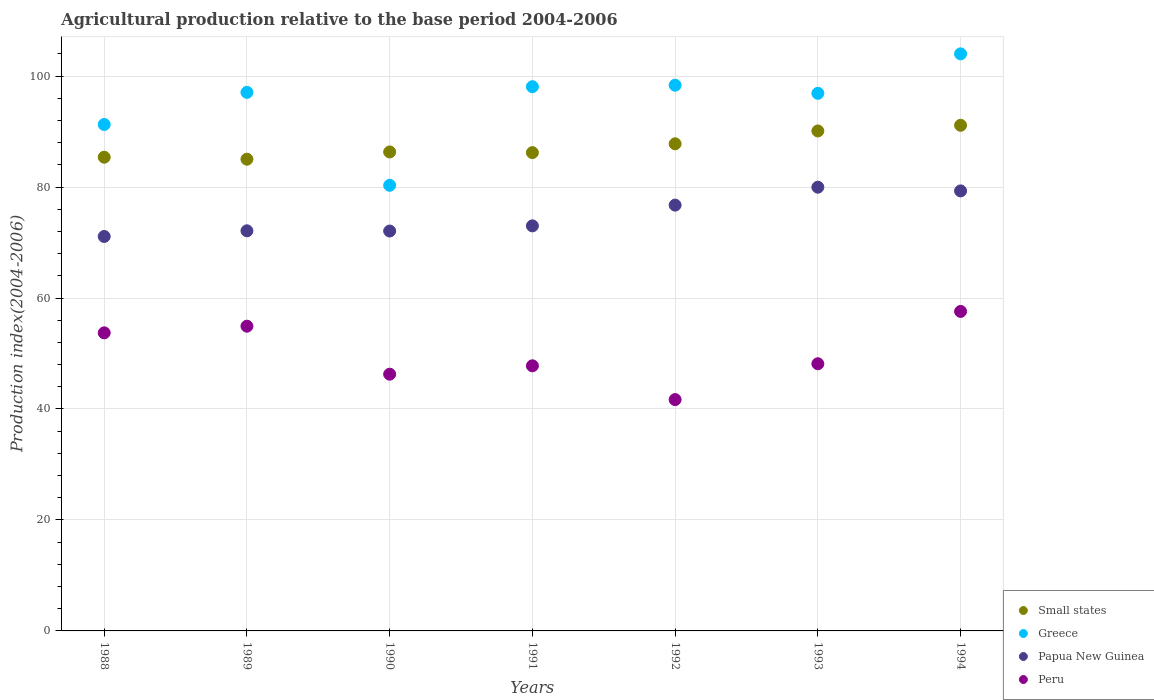How many different coloured dotlines are there?
Make the answer very short. 4. What is the agricultural production index in Greece in 1988?
Your answer should be compact. 91.27. Across all years, what is the maximum agricultural production index in Greece?
Your answer should be compact. 104. Across all years, what is the minimum agricultural production index in Papua New Guinea?
Provide a short and direct response. 71.09. In which year was the agricultural production index in Papua New Guinea minimum?
Make the answer very short. 1988. What is the total agricultural production index in Small states in the graph?
Your answer should be very brief. 611.93. What is the difference between the agricultural production index in Small states in 1993 and that in 1994?
Provide a short and direct response. -1.02. What is the difference between the agricultural production index in Greece in 1992 and the agricultural production index in Papua New Guinea in 1990?
Provide a succinct answer. 26.28. What is the average agricultural production index in Peru per year?
Ensure brevity in your answer.  50.02. In the year 1988, what is the difference between the agricultural production index in Greece and agricultural production index in Peru?
Your answer should be very brief. 37.55. In how many years, is the agricultural production index in Peru greater than 40?
Provide a succinct answer. 7. What is the ratio of the agricultural production index in Peru in 1989 to that in 1993?
Offer a very short reply. 1.14. Is the agricultural production index in Peru in 1991 less than that in 1994?
Your response must be concise. Yes. What is the difference between the highest and the second highest agricultural production index in Peru?
Your answer should be very brief. 2.66. What is the difference between the highest and the lowest agricultural production index in Small states?
Offer a very short reply. 6.11. In how many years, is the agricultural production index in Papua New Guinea greater than the average agricultural production index in Papua New Guinea taken over all years?
Provide a succinct answer. 3. Is it the case that in every year, the sum of the agricultural production index in Small states and agricultural production index in Papua New Guinea  is greater than the agricultural production index in Greece?
Give a very brief answer. Yes. What is the difference between two consecutive major ticks on the Y-axis?
Provide a short and direct response. 20. Does the graph contain any zero values?
Your answer should be compact. No. How many legend labels are there?
Give a very brief answer. 4. What is the title of the graph?
Offer a terse response. Agricultural production relative to the base period 2004-2006. What is the label or title of the X-axis?
Make the answer very short. Years. What is the label or title of the Y-axis?
Offer a terse response. Production index(2004-2006). What is the Production index(2004-2006) of Small states in 1988?
Provide a short and direct response. 85.37. What is the Production index(2004-2006) in Greece in 1988?
Make the answer very short. 91.27. What is the Production index(2004-2006) in Papua New Guinea in 1988?
Give a very brief answer. 71.09. What is the Production index(2004-2006) in Peru in 1988?
Your answer should be very brief. 53.72. What is the Production index(2004-2006) in Small states in 1989?
Keep it short and to the point. 85.01. What is the Production index(2004-2006) of Greece in 1989?
Give a very brief answer. 97.06. What is the Production index(2004-2006) in Papua New Guinea in 1989?
Offer a terse response. 72.11. What is the Production index(2004-2006) of Peru in 1989?
Give a very brief answer. 54.92. What is the Production index(2004-2006) in Small states in 1990?
Keep it short and to the point. 86.32. What is the Production index(2004-2006) of Greece in 1990?
Keep it short and to the point. 80.31. What is the Production index(2004-2006) of Papua New Guinea in 1990?
Ensure brevity in your answer.  72.07. What is the Production index(2004-2006) of Peru in 1990?
Make the answer very short. 46.27. What is the Production index(2004-2006) in Small states in 1991?
Provide a succinct answer. 86.2. What is the Production index(2004-2006) in Greece in 1991?
Offer a very short reply. 98.08. What is the Production index(2004-2006) of Papua New Guinea in 1991?
Keep it short and to the point. 73. What is the Production index(2004-2006) in Peru in 1991?
Make the answer very short. 47.78. What is the Production index(2004-2006) in Small states in 1992?
Ensure brevity in your answer.  87.79. What is the Production index(2004-2006) in Greece in 1992?
Give a very brief answer. 98.35. What is the Production index(2004-2006) of Papua New Guinea in 1992?
Your response must be concise. 76.74. What is the Production index(2004-2006) of Peru in 1992?
Keep it short and to the point. 41.69. What is the Production index(2004-2006) of Small states in 1993?
Provide a succinct answer. 90.1. What is the Production index(2004-2006) in Greece in 1993?
Make the answer very short. 96.89. What is the Production index(2004-2006) of Papua New Guinea in 1993?
Make the answer very short. 79.97. What is the Production index(2004-2006) of Peru in 1993?
Provide a short and direct response. 48.15. What is the Production index(2004-2006) of Small states in 1994?
Provide a succinct answer. 91.13. What is the Production index(2004-2006) in Greece in 1994?
Offer a very short reply. 104. What is the Production index(2004-2006) in Papua New Guinea in 1994?
Your answer should be very brief. 79.3. What is the Production index(2004-2006) in Peru in 1994?
Your answer should be compact. 57.58. Across all years, what is the maximum Production index(2004-2006) in Small states?
Offer a very short reply. 91.13. Across all years, what is the maximum Production index(2004-2006) of Greece?
Offer a terse response. 104. Across all years, what is the maximum Production index(2004-2006) in Papua New Guinea?
Ensure brevity in your answer.  79.97. Across all years, what is the maximum Production index(2004-2006) in Peru?
Keep it short and to the point. 57.58. Across all years, what is the minimum Production index(2004-2006) in Small states?
Offer a terse response. 85.01. Across all years, what is the minimum Production index(2004-2006) of Greece?
Your response must be concise. 80.31. Across all years, what is the minimum Production index(2004-2006) in Papua New Guinea?
Offer a very short reply. 71.09. Across all years, what is the minimum Production index(2004-2006) of Peru?
Ensure brevity in your answer.  41.69. What is the total Production index(2004-2006) in Small states in the graph?
Offer a terse response. 611.93. What is the total Production index(2004-2006) of Greece in the graph?
Your response must be concise. 665.96. What is the total Production index(2004-2006) of Papua New Guinea in the graph?
Ensure brevity in your answer.  524.28. What is the total Production index(2004-2006) in Peru in the graph?
Make the answer very short. 350.11. What is the difference between the Production index(2004-2006) of Small states in 1988 and that in 1989?
Your answer should be compact. 0.36. What is the difference between the Production index(2004-2006) of Greece in 1988 and that in 1989?
Offer a terse response. -5.79. What is the difference between the Production index(2004-2006) of Papua New Guinea in 1988 and that in 1989?
Your answer should be compact. -1.02. What is the difference between the Production index(2004-2006) in Small states in 1988 and that in 1990?
Make the answer very short. -0.95. What is the difference between the Production index(2004-2006) of Greece in 1988 and that in 1990?
Provide a short and direct response. 10.96. What is the difference between the Production index(2004-2006) in Papua New Guinea in 1988 and that in 1990?
Offer a terse response. -0.98. What is the difference between the Production index(2004-2006) of Peru in 1988 and that in 1990?
Your answer should be compact. 7.45. What is the difference between the Production index(2004-2006) of Small states in 1988 and that in 1991?
Offer a terse response. -0.83. What is the difference between the Production index(2004-2006) of Greece in 1988 and that in 1991?
Offer a very short reply. -6.81. What is the difference between the Production index(2004-2006) of Papua New Guinea in 1988 and that in 1991?
Provide a succinct answer. -1.91. What is the difference between the Production index(2004-2006) of Peru in 1988 and that in 1991?
Provide a short and direct response. 5.94. What is the difference between the Production index(2004-2006) in Small states in 1988 and that in 1992?
Make the answer very short. -2.42. What is the difference between the Production index(2004-2006) in Greece in 1988 and that in 1992?
Make the answer very short. -7.08. What is the difference between the Production index(2004-2006) in Papua New Guinea in 1988 and that in 1992?
Ensure brevity in your answer.  -5.65. What is the difference between the Production index(2004-2006) in Peru in 1988 and that in 1992?
Your answer should be very brief. 12.03. What is the difference between the Production index(2004-2006) in Small states in 1988 and that in 1993?
Your answer should be very brief. -4.73. What is the difference between the Production index(2004-2006) in Greece in 1988 and that in 1993?
Give a very brief answer. -5.62. What is the difference between the Production index(2004-2006) of Papua New Guinea in 1988 and that in 1993?
Your answer should be compact. -8.88. What is the difference between the Production index(2004-2006) of Peru in 1988 and that in 1993?
Your answer should be very brief. 5.57. What is the difference between the Production index(2004-2006) of Small states in 1988 and that in 1994?
Your response must be concise. -5.75. What is the difference between the Production index(2004-2006) in Greece in 1988 and that in 1994?
Provide a succinct answer. -12.73. What is the difference between the Production index(2004-2006) in Papua New Guinea in 1988 and that in 1994?
Your answer should be very brief. -8.21. What is the difference between the Production index(2004-2006) of Peru in 1988 and that in 1994?
Keep it short and to the point. -3.86. What is the difference between the Production index(2004-2006) in Small states in 1989 and that in 1990?
Your answer should be very brief. -1.31. What is the difference between the Production index(2004-2006) of Greece in 1989 and that in 1990?
Offer a terse response. 16.75. What is the difference between the Production index(2004-2006) in Papua New Guinea in 1989 and that in 1990?
Give a very brief answer. 0.04. What is the difference between the Production index(2004-2006) of Peru in 1989 and that in 1990?
Offer a terse response. 8.65. What is the difference between the Production index(2004-2006) of Small states in 1989 and that in 1991?
Make the answer very short. -1.19. What is the difference between the Production index(2004-2006) of Greece in 1989 and that in 1991?
Your answer should be very brief. -1.02. What is the difference between the Production index(2004-2006) in Papua New Guinea in 1989 and that in 1991?
Your response must be concise. -0.89. What is the difference between the Production index(2004-2006) of Peru in 1989 and that in 1991?
Provide a succinct answer. 7.14. What is the difference between the Production index(2004-2006) in Small states in 1989 and that in 1992?
Ensure brevity in your answer.  -2.78. What is the difference between the Production index(2004-2006) in Greece in 1989 and that in 1992?
Make the answer very short. -1.29. What is the difference between the Production index(2004-2006) in Papua New Guinea in 1989 and that in 1992?
Your answer should be compact. -4.63. What is the difference between the Production index(2004-2006) in Peru in 1989 and that in 1992?
Provide a short and direct response. 13.23. What is the difference between the Production index(2004-2006) of Small states in 1989 and that in 1993?
Offer a very short reply. -5.09. What is the difference between the Production index(2004-2006) in Greece in 1989 and that in 1993?
Provide a succinct answer. 0.17. What is the difference between the Production index(2004-2006) in Papua New Guinea in 1989 and that in 1993?
Your answer should be very brief. -7.86. What is the difference between the Production index(2004-2006) of Peru in 1989 and that in 1993?
Offer a very short reply. 6.77. What is the difference between the Production index(2004-2006) of Small states in 1989 and that in 1994?
Provide a short and direct response. -6.11. What is the difference between the Production index(2004-2006) of Greece in 1989 and that in 1994?
Your answer should be compact. -6.94. What is the difference between the Production index(2004-2006) of Papua New Guinea in 1989 and that in 1994?
Keep it short and to the point. -7.19. What is the difference between the Production index(2004-2006) of Peru in 1989 and that in 1994?
Your answer should be compact. -2.66. What is the difference between the Production index(2004-2006) in Small states in 1990 and that in 1991?
Offer a very short reply. 0.12. What is the difference between the Production index(2004-2006) of Greece in 1990 and that in 1991?
Make the answer very short. -17.77. What is the difference between the Production index(2004-2006) of Papua New Guinea in 1990 and that in 1991?
Give a very brief answer. -0.93. What is the difference between the Production index(2004-2006) of Peru in 1990 and that in 1991?
Make the answer very short. -1.51. What is the difference between the Production index(2004-2006) of Small states in 1990 and that in 1992?
Provide a succinct answer. -1.47. What is the difference between the Production index(2004-2006) in Greece in 1990 and that in 1992?
Offer a very short reply. -18.04. What is the difference between the Production index(2004-2006) in Papua New Guinea in 1990 and that in 1992?
Your answer should be very brief. -4.67. What is the difference between the Production index(2004-2006) of Peru in 1990 and that in 1992?
Ensure brevity in your answer.  4.58. What is the difference between the Production index(2004-2006) in Small states in 1990 and that in 1993?
Provide a succinct answer. -3.78. What is the difference between the Production index(2004-2006) in Greece in 1990 and that in 1993?
Give a very brief answer. -16.58. What is the difference between the Production index(2004-2006) in Papua New Guinea in 1990 and that in 1993?
Offer a terse response. -7.9. What is the difference between the Production index(2004-2006) of Peru in 1990 and that in 1993?
Your response must be concise. -1.88. What is the difference between the Production index(2004-2006) of Small states in 1990 and that in 1994?
Give a very brief answer. -4.8. What is the difference between the Production index(2004-2006) of Greece in 1990 and that in 1994?
Your response must be concise. -23.69. What is the difference between the Production index(2004-2006) in Papua New Guinea in 1990 and that in 1994?
Your answer should be very brief. -7.23. What is the difference between the Production index(2004-2006) in Peru in 1990 and that in 1994?
Offer a terse response. -11.31. What is the difference between the Production index(2004-2006) in Small states in 1991 and that in 1992?
Provide a succinct answer. -1.59. What is the difference between the Production index(2004-2006) of Greece in 1991 and that in 1992?
Provide a short and direct response. -0.27. What is the difference between the Production index(2004-2006) in Papua New Guinea in 1991 and that in 1992?
Give a very brief answer. -3.74. What is the difference between the Production index(2004-2006) in Peru in 1991 and that in 1992?
Ensure brevity in your answer.  6.09. What is the difference between the Production index(2004-2006) of Small states in 1991 and that in 1993?
Give a very brief answer. -3.9. What is the difference between the Production index(2004-2006) of Greece in 1991 and that in 1993?
Your answer should be very brief. 1.19. What is the difference between the Production index(2004-2006) in Papua New Guinea in 1991 and that in 1993?
Your response must be concise. -6.97. What is the difference between the Production index(2004-2006) in Peru in 1991 and that in 1993?
Provide a succinct answer. -0.37. What is the difference between the Production index(2004-2006) of Small states in 1991 and that in 1994?
Your answer should be compact. -4.92. What is the difference between the Production index(2004-2006) of Greece in 1991 and that in 1994?
Make the answer very short. -5.92. What is the difference between the Production index(2004-2006) in Papua New Guinea in 1991 and that in 1994?
Offer a very short reply. -6.3. What is the difference between the Production index(2004-2006) of Peru in 1991 and that in 1994?
Offer a terse response. -9.8. What is the difference between the Production index(2004-2006) of Small states in 1992 and that in 1993?
Provide a succinct answer. -2.31. What is the difference between the Production index(2004-2006) of Greece in 1992 and that in 1993?
Offer a very short reply. 1.46. What is the difference between the Production index(2004-2006) in Papua New Guinea in 1992 and that in 1993?
Provide a short and direct response. -3.23. What is the difference between the Production index(2004-2006) of Peru in 1992 and that in 1993?
Give a very brief answer. -6.46. What is the difference between the Production index(2004-2006) in Small states in 1992 and that in 1994?
Give a very brief answer. -3.33. What is the difference between the Production index(2004-2006) of Greece in 1992 and that in 1994?
Your answer should be very brief. -5.65. What is the difference between the Production index(2004-2006) of Papua New Guinea in 1992 and that in 1994?
Ensure brevity in your answer.  -2.56. What is the difference between the Production index(2004-2006) in Peru in 1992 and that in 1994?
Provide a short and direct response. -15.89. What is the difference between the Production index(2004-2006) of Small states in 1993 and that in 1994?
Offer a very short reply. -1.02. What is the difference between the Production index(2004-2006) in Greece in 1993 and that in 1994?
Your response must be concise. -7.11. What is the difference between the Production index(2004-2006) in Papua New Guinea in 1993 and that in 1994?
Offer a terse response. 0.67. What is the difference between the Production index(2004-2006) of Peru in 1993 and that in 1994?
Give a very brief answer. -9.43. What is the difference between the Production index(2004-2006) in Small states in 1988 and the Production index(2004-2006) in Greece in 1989?
Offer a very short reply. -11.69. What is the difference between the Production index(2004-2006) in Small states in 1988 and the Production index(2004-2006) in Papua New Guinea in 1989?
Ensure brevity in your answer.  13.26. What is the difference between the Production index(2004-2006) in Small states in 1988 and the Production index(2004-2006) in Peru in 1989?
Ensure brevity in your answer.  30.45. What is the difference between the Production index(2004-2006) in Greece in 1988 and the Production index(2004-2006) in Papua New Guinea in 1989?
Ensure brevity in your answer.  19.16. What is the difference between the Production index(2004-2006) of Greece in 1988 and the Production index(2004-2006) of Peru in 1989?
Make the answer very short. 36.35. What is the difference between the Production index(2004-2006) of Papua New Guinea in 1988 and the Production index(2004-2006) of Peru in 1989?
Your answer should be compact. 16.17. What is the difference between the Production index(2004-2006) of Small states in 1988 and the Production index(2004-2006) of Greece in 1990?
Offer a terse response. 5.06. What is the difference between the Production index(2004-2006) of Small states in 1988 and the Production index(2004-2006) of Papua New Guinea in 1990?
Your response must be concise. 13.3. What is the difference between the Production index(2004-2006) of Small states in 1988 and the Production index(2004-2006) of Peru in 1990?
Your answer should be compact. 39.1. What is the difference between the Production index(2004-2006) of Greece in 1988 and the Production index(2004-2006) of Papua New Guinea in 1990?
Your response must be concise. 19.2. What is the difference between the Production index(2004-2006) of Greece in 1988 and the Production index(2004-2006) of Peru in 1990?
Keep it short and to the point. 45. What is the difference between the Production index(2004-2006) in Papua New Guinea in 1988 and the Production index(2004-2006) in Peru in 1990?
Make the answer very short. 24.82. What is the difference between the Production index(2004-2006) of Small states in 1988 and the Production index(2004-2006) of Greece in 1991?
Your answer should be very brief. -12.71. What is the difference between the Production index(2004-2006) in Small states in 1988 and the Production index(2004-2006) in Papua New Guinea in 1991?
Your answer should be compact. 12.37. What is the difference between the Production index(2004-2006) of Small states in 1988 and the Production index(2004-2006) of Peru in 1991?
Provide a succinct answer. 37.59. What is the difference between the Production index(2004-2006) of Greece in 1988 and the Production index(2004-2006) of Papua New Guinea in 1991?
Keep it short and to the point. 18.27. What is the difference between the Production index(2004-2006) of Greece in 1988 and the Production index(2004-2006) of Peru in 1991?
Offer a very short reply. 43.49. What is the difference between the Production index(2004-2006) in Papua New Guinea in 1988 and the Production index(2004-2006) in Peru in 1991?
Provide a short and direct response. 23.31. What is the difference between the Production index(2004-2006) of Small states in 1988 and the Production index(2004-2006) of Greece in 1992?
Provide a short and direct response. -12.98. What is the difference between the Production index(2004-2006) in Small states in 1988 and the Production index(2004-2006) in Papua New Guinea in 1992?
Your answer should be very brief. 8.63. What is the difference between the Production index(2004-2006) in Small states in 1988 and the Production index(2004-2006) in Peru in 1992?
Offer a very short reply. 43.68. What is the difference between the Production index(2004-2006) in Greece in 1988 and the Production index(2004-2006) in Papua New Guinea in 1992?
Give a very brief answer. 14.53. What is the difference between the Production index(2004-2006) of Greece in 1988 and the Production index(2004-2006) of Peru in 1992?
Provide a short and direct response. 49.58. What is the difference between the Production index(2004-2006) of Papua New Guinea in 1988 and the Production index(2004-2006) of Peru in 1992?
Give a very brief answer. 29.4. What is the difference between the Production index(2004-2006) of Small states in 1988 and the Production index(2004-2006) of Greece in 1993?
Your response must be concise. -11.52. What is the difference between the Production index(2004-2006) in Small states in 1988 and the Production index(2004-2006) in Papua New Guinea in 1993?
Your answer should be very brief. 5.4. What is the difference between the Production index(2004-2006) in Small states in 1988 and the Production index(2004-2006) in Peru in 1993?
Provide a succinct answer. 37.22. What is the difference between the Production index(2004-2006) in Greece in 1988 and the Production index(2004-2006) in Peru in 1993?
Keep it short and to the point. 43.12. What is the difference between the Production index(2004-2006) of Papua New Guinea in 1988 and the Production index(2004-2006) of Peru in 1993?
Ensure brevity in your answer.  22.94. What is the difference between the Production index(2004-2006) of Small states in 1988 and the Production index(2004-2006) of Greece in 1994?
Keep it short and to the point. -18.63. What is the difference between the Production index(2004-2006) in Small states in 1988 and the Production index(2004-2006) in Papua New Guinea in 1994?
Give a very brief answer. 6.07. What is the difference between the Production index(2004-2006) in Small states in 1988 and the Production index(2004-2006) in Peru in 1994?
Your response must be concise. 27.79. What is the difference between the Production index(2004-2006) of Greece in 1988 and the Production index(2004-2006) of Papua New Guinea in 1994?
Provide a short and direct response. 11.97. What is the difference between the Production index(2004-2006) of Greece in 1988 and the Production index(2004-2006) of Peru in 1994?
Offer a terse response. 33.69. What is the difference between the Production index(2004-2006) in Papua New Guinea in 1988 and the Production index(2004-2006) in Peru in 1994?
Ensure brevity in your answer.  13.51. What is the difference between the Production index(2004-2006) of Small states in 1989 and the Production index(2004-2006) of Greece in 1990?
Your answer should be compact. 4.7. What is the difference between the Production index(2004-2006) of Small states in 1989 and the Production index(2004-2006) of Papua New Guinea in 1990?
Ensure brevity in your answer.  12.94. What is the difference between the Production index(2004-2006) in Small states in 1989 and the Production index(2004-2006) in Peru in 1990?
Give a very brief answer. 38.74. What is the difference between the Production index(2004-2006) of Greece in 1989 and the Production index(2004-2006) of Papua New Guinea in 1990?
Your answer should be very brief. 24.99. What is the difference between the Production index(2004-2006) in Greece in 1989 and the Production index(2004-2006) in Peru in 1990?
Provide a short and direct response. 50.79. What is the difference between the Production index(2004-2006) of Papua New Guinea in 1989 and the Production index(2004-2006) of Peru in 1990?
Keep it short and to the point. 25.84. What is the difference between the Production index(2004-2006) of Small states in 1989 and the Production index(2004-2006) of Greece in 1991?
Make the answer very short. -13.07. What is the difference between the Production index(2004-2006) of Small states in 1989 and the Production index(2004-2006) of Papua New Guinea in 1991?
Provide a short and direct response. 12.01. What is the difference between the Production index(2004-2006) in Small states in 1989 and the Production index(2004-2006) in Peru in 1991?
Make the answer very short. 37.23. What is the difference between the Production index(2004-2006) in Greece in 1989 and the Production index(2004-2006) in Papua New Guinea in 1991?
Make the answer very short. 24.06. What is the difference between the Production index(2004-2006) of Greece in 1989 and the Production index(2004-2006) of Peru in 1991?
Provide a succinct answer. 49.28. What is the difference between the Production index(2004-2006) in Papua New Guinea in 1989 and the Production index(2004-2006) in Peru in 1991?
Provide a short and direct response. 24.33. What is the difference between the Production index(2004-2006) in Small states in 1989 and the Production index(2004-2006) in Greece in 1992?
Make the answer very short. -13.34. What is the difference between the Production index(2004-2006) of Small states in 1989 and the Production index(2004-2006) of Papua New Guinea in 1992?
Offer a very short reply. 8.27. What is the difference between the Production index(2004-2006) in Small states in 1989 and the Production index(2004-2006) in Peru in 1992?
Your answer should be very brief. 43.32. What is the difference between the Production index(2004-2006) in Greece in 1989 and the Production index(2004-2006) in Papua New Guinea in 1992?
Offer a terse response. 20.32. What is the difference between the Production index(2004-2006) of Greece in 1989 and the Production index(2004-2006) of Peru in 1992?
Provide a short and direct response. 55.37. What is the difference between the Production index(2004-2006) in Papua New Guinea in 1989 and the Production index(2004-2006) in Peru in 1992?
Ensure brevity in your answer.  30.42. What is the difference between the Production index(2004-2006) of Small states in 1989 and the Production index(2004-2006) of Greece in 1993?
Give a very brief answer. -11.88. What is the difference between the Production index(2004-2006) in Small states in 1989 and the Production index(2004-2006) in Papua New Guinea in 1993?
Keep it short and to the point. 5.04. What is the difference between the Production index(2004-2006) in Small states in 1989 and the Production index(2004-2006) in Peru in 1993?
Provide a short and direct response. 36.86. What is the difference between the Production index(2004-2006) in Greece in 1989 and the Production index(2004-2006) in Papua New Guinea in 1993?
Ensure brevity in your answer.  17.09. What is the difference between the Production index(2004-2006) of Greece in 1989 and the Production index(2004-2006) of Peru in 1993?
Offer a terse response. 48.91. What is the difference between the Production index(2004-2006) in Papua New Guinea in 1989 and the Production index(2004-2006) in Peru in 1993?
Your answer should be very brief. 23.96. What is the difference between the Production index(2004-2006) in Small states in 1989 and the Production index(2004-2006) in Greece in 1994?
Make the answer very short. -18.99. What is the difference between the Production index(2004-2006) in Small states in 1989 and the Production index(2004-2006) in Papua New Guinea in 1994?
Offer a terse response. 5.71. What is the difference between the Production index(2004-2006) of Small states in 1989 and the Production index(2004-2006) of Peru in 1994?
Provide a short and direct response. 27.43. What is the difference between the Production index(2004-2006) in Greece in 1989 and the Production index(2004-2006) in Papua New Guinea in 1994?
Your answer should be very brief. 17.76. What is the difference between the Production index(2004-2006) of Greece in 1989 and the Production index(2004-2006) of Peru in 1994?
Offer a very short reply. 39.48. What is the difference between the Production index(2004-2006) in Papua New Guinea in 1989 and the Production index(2004-2006) in Peru in 1994?
Your answer should be compact. 14.53. What is the difference between the Production index(2004-2006) in Small states in 1990 and the Production index(2004-2006) in Greece in 1991?
Offer a terse response. -11.76. What is the difference between the Production index(2004-2006) in Small states in 1990 and the Production index(2004-2006) in Papua New Guinea in 1991?
Give a very brief answer. 13.32. What is the difference between the Production index(2004-2006) in Small states in 1990 and the Production index(2004-2006) in Peru in 1991?
Your answer should be very brief. 38.54. What is the difference between the Production index(2004-2006) in Greece in 1990 and the Production index(2004-2006) in Papua New Guinea in 1991?
Provide a short and direct response. 7.31. What is the difference between the Production index(2004-2006) of Greece in 1990 and the Production index(2004-2006) of Peru in 1991?
Your answer should be very brief. 32.53. What is the difference between the Production index(2004-2006) of Papua New Guinea in 1990 and the Production index(2004-2006) of Peru in 1991?
Give a very brief answer. 24.29. What is the difference between the Production index(2004-2006) in Small states in 1990 and the Production index(2004-2006) in Greece in 1992?
Provide a short and direct response. -12.03. What is the difference between the Production index(2004-2006) in Small states in 1990 and the Production index(2004-2006) in Papua New Guinea in 1992?
Your answer should be compact. 9.58. What is the difference between the Production index(2004-2006) in Small states in 1990 and the Production index(2004-2006) in Peru in 1992?
Offer a very short reply. 44.63. What is the difference between the Production index(2004-2006) in Greece in 1990 and the Production index(2004-2006) in Papua New Guinea in 1992?
Provide a short and direct response. 3.57. What is the difference between the Production index(2004-2006) in Greece in 1990 and the Production index(2004-2006) in Peru in 1992?
Provide a succinct answer. 38.62. What is the difference between the Production index(2004-2006) in Papua New Guinea in 1990 and the Production index(2004-2006) in Peru in 1992?
Give a very brief answer. 30.38. What is the difference between the Production index(2004-2006) of Small states in 1990 and the Production index(2004-2006) of Greece in 1993?
Ensure brevity in your answer.  -10.57. What is the difference between the Production index(2004-2006) in Small states in 1990 and the Production index(2004-2006) in Papua New Guinea in 1993?
Make the answer very short. 6.35. What is the difference between the Production index(2004-2006) in Small states in 1990 and the Production index(2004-2006) in Peru in 1993?
Give a very brief answer. 38.17. What is the difference between the Production index(2004-2006) of Greece in 1990 and the Production index(2004-2006) of Papua New Guinea in 1993?
Offer a terse response. 0.34. What is the difference between the Production index(2004-2006) of Greece in 1990 and the Production index(2004-2006) of Peru in 1993?
Give a very brief answer. 32.16. What is the difference between the Production index(2004-2006) of Papua New Guinea in 1990 and the Production index(2004-2006) of Peru in 1993?
Your answer should be compact. 23.92. What is the difference between the Production index(2004-2006) of Small states in 1990 and the Production index(2004-2006) of Greece in 1994?
Your answer should be very brief. -17.68. What is the difference between the Production index(2004-2006) of Small states in 1990 and the Production index(2004-2006) of Papua New Guinea in 1994?
Ensure brevity in your answer.  7.02. What is the difference between the Production index(2004-2006) in Small states in 1990 and the Production index(2004-2006) in Peru in 1994?
Offer a very short reply. 28.74. What is the difference between the Production index(2004-2006) in Greece in 1990 and the Production index(2004-2006) in Papua New Guinea in 1994?
Your response must be concise. 1.01. What is the difference between the Production index(2004-2006) in Greece in 1990 and the Production index(2004-2006) in Peru in 1994?
Your answer should be very brief. 22.73. What is the difference between the Production index(2004-2006) in Papua New Guinea in 1990 and the Production index(2004-2006) in Peru in 1994?
Make the answer very short. 14.49. What is the difference between the Production index(2004-2006) in Small states in 1991 and the Production index(2004-2006) in Greece in 1992?
Offer a terse response. -12.15. What is the difference between the Production index(2004-2006) in Small states in 1991 and the Production index(2004-2006) in Papua New Guinea in 1992?
Your answer should be compact. 9.46. What is the difference between the Production index(2004-2006) in Small states in 1991 and the Production index(2004-2006) in Peru in 1992?
Ensure brevity in your answer.  44.51. What is the difference between the Production index(2004-2006) in Greece in 1991 and the Production index(2004-2006) in Papua New Guinea in 1992?
Keep it short and to the point. 21.34. What is the difference between the Production index(2004-2006) of Greece in 1991 and the Production index(2004-2006) of Peru in 1992?
Offer a very short reply. 56.39. What is the difference between the Production index(2004-2006) in Papua New Guinea in 1991 and the Production index(2004-2006) in Peru in 1992?
Keep it short and to the point. 31.31. What is the difference between the Production index(2004-2006) in Small states in 1991 and the Production index(2004-2006) in Greece in 1993?
Your answer should be very brief. -10.69. What is the difference between the Production index(2004-2006) in Small states in 1991 and the Production index(2004-2006) in Papua New Guinea in 1993?
Your answer should be compact. 6.23. What is the difference between the Production index(2004-2006) of Small states in 1991 and the Production index(2004-2006) of Peru in 1993?
Your response must be concise. 38.05. What is the difference between the Production index(2004-2006) of Greece in 1991 and the Production index(2004-2006) of Papua New Guinea in 1993?
Give a very brief answer. 18.11. What is the difference between the Production index(2004-2006) of Greece in 1991 and the Production index(2004-2006) of Peru in 1993?
Make the answer very short. 49.93. What is the difference between the Production index(2004-2006) of Papua New Guinea in 1991 and the Production index(2004-2006) of Peru in 1993?
Offer a terse response. 24.85. What is the difference between the Production index(2004-2006) of Small states in 1991 and the Production index(2004-2006) of Greece in 1994?
Provide a succinct answer. -17.8. What is the difference between the Production index(2004-2006) in Small states in 1991 and the Production index(2004-2006) in Papua New Guinea in 1994?
Make the answer very short. 6.9. What is the difference between the Production index(2004-2006) in Small states in 1991 and the Production index(2004-2006) in Peru in 1994?
Your answer should be compact. 28.62. What is the difference between the Production index(2004-2006) of Greece in 1991 and the Production index(2004-2006) of Papua New Guinea in 1994?
Ensure brevity in your answer.  18.78. What is the difference between the Production index(2004-2006) of Greece in 1991 and the Production index(2004-2006) of Peru in 1994?
Give a very brief answer. 40.5. What is the difference between the Production index(2004-2006) of Papua New Guinea in 1991 and the Production index(2004-2006) of Peru in 1994?
Your response must be concise. 15.42. What is the difference between the Production index(2004-2006) of Small states in 1992 and the Production index(2004-2006) of Greece in 1993?
Make the answer very short. -9.1. What is the difference between the Production index(2004-2006) in Small states in 1992 and the Production index(2004-2006) in Papua New Guinea in 1993?
Provide a succinct answer. 7.82. What is the difference between the Production index(2004-2006) of Small states in 1992 and the Production index(2004-2006) of Peru in 1993?
Your answer should be compact. 39.64. What is the difference between the Production index(2004-2006) in Greece in 1992 and the Production index(2004-2006) in Papua New Guinea in 1993?
Your answer should be very brief. 18.38. What is the difference between the Production index(2004-2006) in Greece in 1992 and the Production index(2004-2006) in Peru in 1993?
Give a very brief answer. 50.2. What is the difference between the Production index(2004-2006) in Papua New Guinea in 1992 and the Production index(2004-2006) in Peru in 1993?
Provide a succinct answer. 28.59. What is the difference between the Production index(2004-2006) of Small states in 1992 and the Production index(2004-2006) of Greece in 1994?
Give a very brief answer. -16.21. What is the difference between the Production index(2004-2006) of Small states in 1992 and the Production index(2004-2006) of Papua New Guinea in 1994?
Offer a terse response. 8.49. What is the difference between the Production index(2004-2006) of Small states in 1992 and the Production index(2004-2006) of Peru in 1994?
Offer a terse response. 30.21. What is the difference between the Production index(2004-2006) in Greece in 1992 and the Production index(2004-2006) in Papua New Guinea in 1994?
Your answer should be very brief. 19.05. What is the difference between the Production index(2004-2006) of Greece in 1992 and the Production index(2004-2006) of Peru in 1994?
Ensure brevity in your answer.  40.77. What is the difference between the Production index(2004-2006) in Papua New Guinea in 1992 and the Production index(2004-2006) in Peru in 1994?
Give a very brief answer. 19.16. What is the difference between the Production index(2004-2006) in Small states in 1993 and the Production index(2004-2006) in Greece in 1994?
Provide a short and direct response. -13.9. What is the difference between the Production index(2004-2006) in Small states in 1993 and the Production index(2004-2006) in Papua New Guinea in 1994?
Make the answer very short. 10.8. What is the difference between the Production index(2004-2006) of Small states in 1993 and the Production index(2004-2006) of Peru in 1994?
Your response must be concise. 32.52. What is the difference between the Production index(2004-2006) in Greece in 1993 and the Production index(2004-2006) in Papua New Guinea in 1994?
Offer a very short reply. 17.59. What is the difference between the Production index(2004-2006) of Greece in 1993 and the Production index(2004-2006) of Peru in 1994?
Offer a very short reply. 39.31. What is the difference between the Production index(2004-2006) in Papua New Guinea in 1993 and the Production index(2004-2006) in Peru in 1994?
Your response must be concise. 22.39. What is the average Production index(2004-2006) in Small states per year?
Your answer should be compact. 87.42. What is the average Production index(2004-2006) of Greece per year?
Your response must be concise. 95.14. What is the average Production index(2004-2006) of Papua New Guinea per year?
Keep it short and to the point. 74.9. What is the average Production index(2004-2006) of Peru per year?
Provide a short and direct response. 50.02. In the year 1988, what is the difference between the Production index(2004-2006) in Small states and Production index(2004-2006) in Greece?
Offer a very short reply. -5.9. In the year 1988, what is the difference between the Production index(2004-2006) in Small states and Production index(2004-2006) in Papua New Guinea?
Keep it short and to the point. 14.28. In the year 1988, what is the difference between the Production index(2004-2006) of Small states and Production index(2004-2006) of Peru?
Make the answer very short. 31.65. In the year 1988, what is the difference between the Production index(2004-2006) of Greece and Production index(2004-2006) of Papua New Guinea?
Keep it short and to the point. 20.18. In the year 1988, what is the difference between the Production index(2004-2006) in Greece and Production index(2004-2006) in Peru?
Your answer should be compact. 37.55. In the year 1988, what is the difference between the Production index(2004-2006) of Papua New Guinea and Production index(2004-2006) of Peru?
Your response must be concise. 17.37. In the year 1989, what is the difference between the Production index(2004-2006) in Small states and Production index(2004-2006) in Greece?
Make the answer very short. -12.05. In the year 1989, what is the difference between the Production index(2004-2006) in Small states and Production index(2004-2006) in Papua New Guinea?
Your answer should be compact. 12.9. In the year 1989, what is the difference between the Production index(2004-2006) of Small states and Production index(2004-2006) of Peru?
Provide a succinct answer. 30.09. In the year 1989, what is the difference between the Production index(2004-2006) of Greece and Production index(2004-2006) of Papua New Guinea?
Offer a terse response. 24.95. In the year 1989, what is the difference between the Production index(2004-2006) in Greece and Production index(2004-2006) in Peru?
Your answer should be very brief. 42.14. In the year 1989, what is the difference between the Production index(2004-2006) in Papua New Guinea and Production index(2004-2006) in Peru?
Provide a short and direct response. 17.19. In the year 1990, what is the difference between the Production index(2004-2006) of Small states and Production index(2004-2006) of Greece?
Offer a very short reply. 6.01. In the year 1990, what is the difference between the Production index(2004-2006) in Small states and Production index(2004-2006) in Papua New Guinea?
Provide a short and direct response. 14.25. In the year 1990, what is the difference between the Production index(2004-2006) of Small states and Production index(2004-2006) of Peru?
Your response must be concise. 40.05. In the year 1990, what is the difference between the Production index(2004-2006) in Greece and Production index(2004-2006) in Papua New Guinea?
Offer a terse response. 8.24. In the year 1990, what is the difference between the Production index(2004-2006) of Greece and Production index(2004-2006) of Peru?
Provide a succinct answer. 34.04. In the year 1990, what is the difference between the Production index(2004-2006) of Papua New Guinea and Production index(2004-2006) of Peru?
Your response must be concise. 25.8. In the year 1991, what is the difference between the Production index(2004-2006) in Small states and Production index(2004-2006) in Greece?
Offer a very short reply. -11.88. In the year 1991, what is the difference between the Production index(2004-2006) of Small states and Production index(2004-2006) of Papua New Guinea?
Make the answer very short. 13.2. In the year 1991, what is the difference between the Production index(2004-2006) of Small states and Production index(2004-2006) of Peru?
Provide a succinct answer. 38.42. In the year 1991, what is the difference between the Production index(2004-2006) of Greece and Production index(2004-2006) of Papua New Guinea?
Offer a very short reply. 25.08. In the year 1991, what is the difference between the Production index(2004-2006) in Greece and Production index(2004-2006) in Peru?
Give a very brief answer. 50.3. In the year 1991, what is the difference between the Production index(2004-2006) of Papua New Guinea and Production index(2004-2006) of Peru?
Your response must be concise. 25.22. In the year 1992, what is the difference between the Production index(2004-2006) in Small states and Production index(2004-2006) in Greece?
Give a very brief answer. -10.56. In the year 1992, what is the difference between the Production index(2004-2006) in Small states and Production index(2004-2006) in Papua New Guinea?
Your answer should be compact. 11.05. In the year 1992, what is the difference between the Production index(2004-2006) of Small states and Production index(2004-2006) of Peru?
Offer a terse response. 46.1. In the year 1992, what is the difference between the Production index(2004-2006) of Greece and Production index(2004-2006) of Papua New Guinea?
Your response must be concise. 21.61. In the year 1992, what is the difference between the Production index(2004-2006) of Greece and Production index(2004-2006) of Peru?
Your response must be concise. 56.66. In the year 1992, what is the difference between the Production index(2004-2006) in Papua New Guinea and Production index(2004-2006) in Peru?
Give a very brief answer. 35.05. In the year 1993, what is the difference between the Production index(2004-2006) of Small states and Production index(2004-2006) of Greece?
Keep it short and to the point. -6.79. In the year 1993, what is the difference between the Production index(2004-2006) of Small states and Production index(2004-2006) of Papua New Guinea?
Ensure brevity in your answer.  10.13. In the year 1993, what is the difference between the Production index(2004-2006) of Small states and Production index(2004-2006) of Peru?
Provide a succinct answer. 41.95. In the year 1993, what is the difference between the Production index(2004-2006) in Greece and Production index(2004-2006) in Papua New Guinea?
Provide a succinct answer. 16.92. In the year 1993, what is the difference between the Production index(2004-2006) in Greece and Production index(2004-2006) in Peru?
Your answer should be very brief. 48.74. In the year 1993, what is the difference between the Production index(2004-2006) of Papua New Guinea and Production index(2004-2006) of Peru?
Your answer should be very brief. 31.82. In the year 1994, what is the difference between the Production index(2004-2006) in Small states and Production index(2004-2006) in Greece?
Your response must be concise. -12.87. In the year 1994, what is the difference between the Production index(2004-2006) of Small states and Production index(2004-2006) of Papua New Guinea?
Give a very brief answer. 11.83. In the year 1994, what is the difference between the Production index(2004-2006) in Small states and Production index(2004-2006) in Peru?
Ensure brevity in your answer.  33.55. In the year 1994, what is the difference between the Production index(2004-2006) in Greece and Production index(2004-2006) in Papua New Guinea?
Your response must be concise. 24.7. In the year 1994, what is the difference between the Production index(2004-2006) in Greece and Production index(2004-2006) in Peru?
Offer a very short reply. 46.42. In the year 1994, what is the difference between the Production index(2004-2006) of Papua New Guinea and Production index(2004-2006) of Peru?
Offer a terse response. 21.72. What is the ratio of the Production index(2004-2006) of Greece in 1988 to that in 1989?
Keep it short and to the point. 0.94. What is the ratio of the Production index(2004-2006) of Papua New Guinea in 1988 to that in 1989?
Make the answer very short. 0.99. What is the ratio of the Production index(2004-2006) in Peru in 1988 to that in 1989?
Your answer should be compact. 0.98. What is the ratio of the Production index(2004-2006) of Greece in 1988 to that in 1990?
Make the answer very short. 1.14. What is the ratio of the Production index(2004-2006) in Papua New Guinea in 1988 to that in 1990?
Ensure brevity in your answer.  0.99. What is the ratio of the Production index(2004-2006) of Peru in 1988 to that in 1990?
Offer a terse response. 1.16. What is the ratio of the Production index(2004-2006) of Greece in 1988 to that in 1991?
Ensure brevity in your answer.  0.93. What is the ratio of the Production index(2004-2006) in Papua New Guinea in 1988 to that in 1991?
Your response must be concise. 0.97. What is the ratio of the Production index(2004-2006) of Peru in 1988 to that in 1991?
Offer a terse response. 1.12. What is the ratio of the Production index(2004-2006) of Small states in 1988 to that in 1992?
Give a very brief answer. 0.97. What is the ratio of the Production index(2004-2006) of Greece in 1988 to that in 1992?
Offer a terse response. 0.93. What is the ratio of the Production index(2004-2006) of Papua New Guinea in 1988 to that in 1992?
Your response must be concise. 0.93. What is the ratio of the Production index(2004-2006) in Peru in 1988 to that in 1992?
Provide a succinct answer. 1.29. What is the ratio of the Production index(2004-2006) in Small states in 1988 to that in 1993?
Offer a terse response. 0.95. What is the ratio of the Production index(2004-2006) of Greece in 1988 to that in 1993?
Keep it short and to the point. 0.94. What is the ratio of the Production index(2004-2006) of Papua New Guinea in 1988 to that in 1993?
Ensure brevity in your answer.  0.89. What is the ratio of the Production index(2004-2006) in Peru in 1988 to that in 1993?
Your response must be concise. 1.12. What is the ratio of the Production index(2004-2006) of Small states in 1988 to that in 1994?
Offer a terse response. 0.94. What is the ratio of the Production index(2004-2006) in Greece in 1988 to that in 1994?
Offer a very short reply. 0.88. What is the ratio of the Production index(2004-2006) in Papua New Guinea in 1988 to that in 1994?
Your response must be concise. 0.9. What is the ratio of the Production index(2004-2006) of Peru in 1988 to that in 1994?
Provide a short and direct response. 0.93. What is the ratio of the Production index(2004-2006) of Small states in 1989 to that in 1990?
Keep it short and to the point. 0.98. What is the ratio of the Production index(2004-2006) of Greece in 1989 to that in 1990?
Offer a very short reply. 1.21. What is the ratio of the Production index(2004-2006) in Peru in 1989 to that in 1990?
Your answer should be very brief. 1.19. What is the ratio of the Production index(2004-2006) of Small states in 1989 to that in 1991?
Your response must be concise. 0.99. What is the ratio of the Production index(2004-2006) of Peru in 1989 to that in 1991?
Keep it short and to the point. 1.15. What is the ratio of the Production index(2004-2006) of Small states in 1989 to that in 1992?
Your answer should be very brief. 0.97. What is the ratio of the Production index(2004-2006) in Greece in 1989 to that in 1992?
Offer a very short reply. 0.99. What is the ratio of the Production index(2004-2006) in Papua New Guinea in 1989 to that in 1992?
Provide a short and direct response. 0.94. What is the ratio of the Production index(2004-2006) in Peru in 1989 to that in 1992?
Provide a succinct answer. 1.32. What is the ratio of the Production index(2004-2006) of Small states in 1989 to that in 1993?
Give a very brief answer. 0.94. What is the ratio of the Production index(2004-2006) of Greece in 1989 to that in 1993?
Provide a succinct answer. 1. What is the ratio of the Production index(2004-2006) of Papua New Guinea in 1989 to that in 1993?
Offer a terse response. 0.9. What is the ratio of the Production index(2004-2006) of Peru in 1989 to that in 1993?
Your answer should be very brief. 1.14. What is the ratio of the Production index(2004-2006) of Small states in 1989 to that in 1994?
Offer a terse response. 0.93. What is the ratio of the Production index(2004-2006) of Papua New Guinea in 1989 to that in 1994?
Your answer should be compact. 0.91. What is the ratio of the Production index(2004-2006) of Peru in 1989 to that in 1994?
Make the answer very short. 0.95. What is the ratio of the Production index(2004-2006) in Greece in 1990 to that in 1991?
Provide a short and direct response. 0.82. What is the ratio of the Production index(2004-2006) of Papua New Guinea in 1990 to that in 1991?
Give a very brief answer. 0.99. What is the ratio of the Production index(2004-2006) of Peru in 1990 to that in 1991?
Your answer should be very brief. 0.97. What is the ratio of the Production index(2004-2006) of Small states in 1990 to that in 1992?
Offer a terse response. 0.98. What is the ratio of the Production index(2004-2006) in Greece in 1990 to that in 1992?
Provide a succinct answer. 0.82. What is the ratio of the Production index(2004-2006) in Papua New Guinea in 1990 to that in 1992?
Provide a succinct answer. 0.94. What is the ratio of the Production index(2004-2006) in Peru in 1990 to that in 1992?
Your answer should be very brief. 1.11. What is the ratio of the Production index(2004-2006) in Small states in 1990 to that in 1993?
Keep it short and to the point. 0.96. What is the ratio of the Production index(2004-2006) of Greece in 1990 to that in 1993?
Provide a short and direct response. 0.83. What is the ratio of the Production index(2004-2006) of Papua New Guinea in 1990 to that in 1993?
Provide a short and direct response. 0.9. What is the ratio of the Production index(2004-2006) in Small states in 1990 to that in 1994?
Keep it short and to the point. 0.95. What is the ratio of the Production index(2004-2006) of Greece in 1990 to that in 1994?
Offer a terse response. 0.77. What is the ratio of the Production index(2004-2006) in Papua New Guinea in 1990 to that in 1994?
Your answer should be very brief. 0.91. What is the ratio of the Production index(2004-2006) in Peru in 1990 to that in 1994?
Your answer should be very brief. 0.8. What is the ratio of the Production index(2004-2006) of Small states in 1991 to that in 1992?
Provide a succinct answer. 0.98. What is the ratio of the Production index(2004-2006) in Papua New Guinea in 1991 to that in 1992?
Ensure brevity in your answer.  0.95. What is the ratio of the Production index(2004-2006) in Peru in 1991 to that in 1992?
Offer a terse response. 1.15. What is the ratio of the Production index(2004-2006) in Small states in 1991 to that in 1993?
Give a very brief answer. 0.96. What is the ratio of the Production index(2004-2006) in Greece in 1991 to that in 1993?
Provide a succinct answer. 1.01. What is the ratio of the Production index(2004-2006) in Papua New Guinea in 1991 to that in 1993?
Your response must be concise. 0.91. What is the ratio of the Production index(2004-2006) in Small states in 1991 to that in 1994?
Keep it short and to the point. 0.95. What is the ratio of the Production index(2004-2006) in Greece in 1991 to that in 1994?
Offer a very short reply. 0.94. What is the ratio of the Production index(2004-2006) of Papua New Guinea in 1991 to that in 1994?
Offer a very short reply. 0.92. What is the ratio of the Production index(2004-2006) in Peru in 1991 to that in 1994?
Make the answer very short. 0.83. What is the ratio of the Production index(2004-2006) of Small states in 1992 to that in 1993?
Your response must be concise. 0.97. What is the ratio of the Production index(2004-2006) in Greece in 1992 to that in 1993?
Your response must be concise. 1.02. What is the ratio of the Production index(2004-2006) of Papua New Guinea in 1992 to that in 1993?
Offer a very short reply. 0.96. What is the ratio of the Production index(2004-2006) in Peru in 1992 to that in 1993?
Your response must be concise. 0.87. What is the ratio of the Production index(2004-2006) of Small states in 1992 to that in 1994?
Make the answer very short. 0.96. What is the ratio of the Production index(2004-2006) of Greece in 1992 to that in 1994?
Keep it short and to the point. 0.95. What is the ratio of the Production index(2004-2006) in Papua New Guinea in 1992 to that in 1994?
Offer a terse response. 0.97. What is the ratio of the Production index(2004-2006) of Peru in 1992 to that in 1994?
Make the answer very short. 0.72. What is the ratio of the Production index(2004-2006) of Small states in 1993 to that in 1994?
Your answer should be compact. 0.99. What is the ratio of the Production index(2004-2006) of Greece in 1993 to that in 1994?
Your response must be concise. 0.93. What is the ratio of the Production index(2004-2006) in Papua New Guinea in 1993 to that in 1994?
Keep it short and to the point. 1.01. What is the ratio of the Production index(2004-2006) of Peru in 1993 to that in 1994?
Keep it short and to the point. 0.84. What is the difference between the highest and the second highest Production index(2004-2006) of Small states?
Keep it short and to the point. 1.02. What is the difference between the highest and the second highest Production index(2004-2006) in Greece?
Offer a terse response. 5.65. What is the difference between the highest and the second highest Production index(2004-2006) in Papua New Guinea?
Your answer should be very brief. 0.67. What is the difference between the highest and the second highest Production index(2004-2006) of Peru?
Provide a short and direct response. 2.66. What is the difference between the highest and the lowest Production index(2004-2006) of Small states?
Keep it short and to the point. 6.11. What is the difference between the highest and the lowest Production index(2004-2006) in Greece?
Keep it short and to the point. 23.69. What is the difference between the highest and the lowest Production index(2004-2006) of Papua New Guinea?
Give a very brief answer. 8.88. What is the difference between the highest and the lowest Production index(2004-2006) of Peru?
Provide a succinct answer. 15.89. 